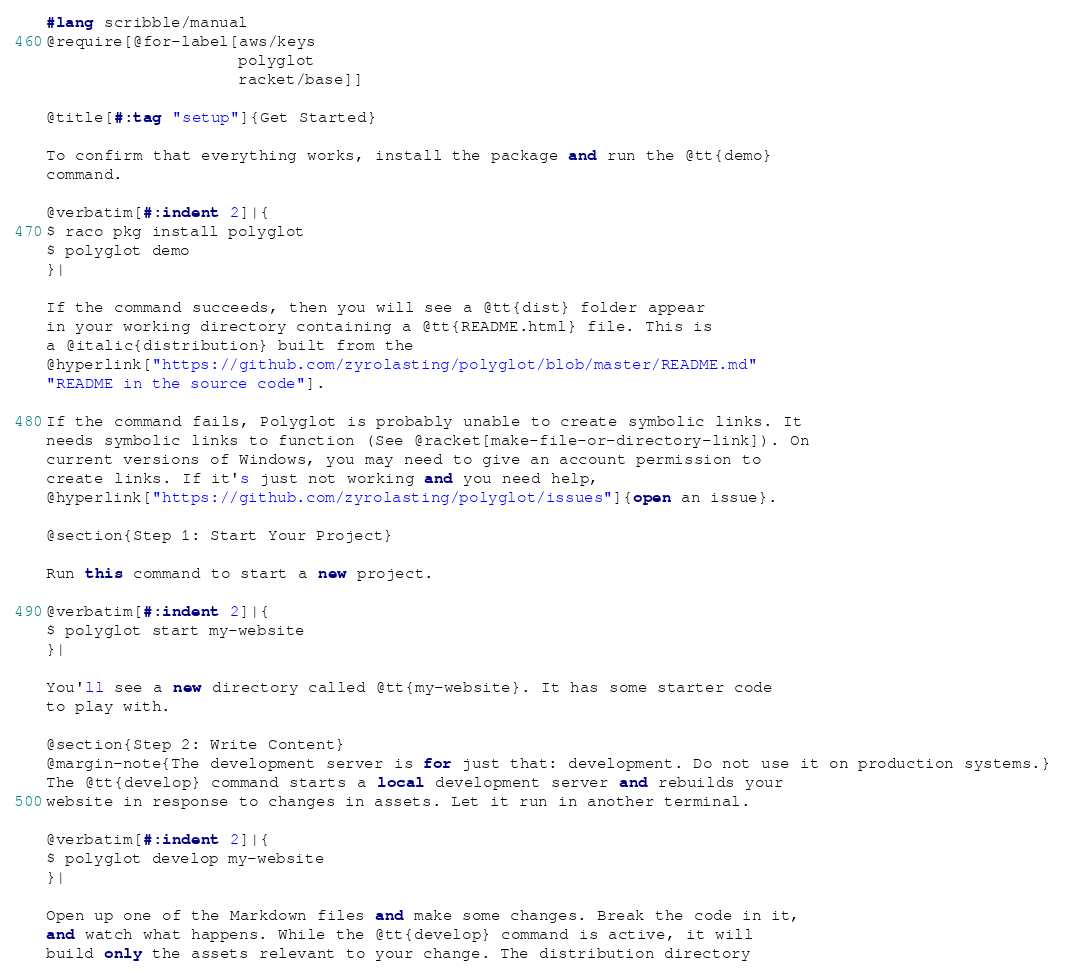<code> <loc_0><loc_0><loc_500><loc_500><_Racket_>#lang scribble/manual
@require[@for-label[aws/keys
                    polyglot
                    racket/base]]

@title[#:tag "setup"]{Get Started}

To confirm that everything works, install the package and run the @tt{demo}
command.

@verbatim[#:indent 2]|{
$ raco pkg install polyglot
$ polyglot demo
}|

If the command succeeds, then you will see a @tt{dist} folder appear
in your working directory containing a @tt{README.html} file. This is
a @italic{distribution} built from the
@hyperlink["https://github.com/zyrolasting/polyglot/blob/master/README.md"
"README in the source code"].

If the command fails, Polyglot is probably unable to create symbolic links. It
needs symbolic links to function (See @racket[make-file-or-directory-link]). On
current versions of Windows, you may need to give an account permission to
create links. If it's just not working and you need help,
@hyperlink["https://github.com/zyrolasting/polyglot/issues"]{open an issue}.

@section{Step 1: Start Your Project}

Run this command to start a new project.

@verbatim[#:indent 2]|{
$ polyglot start my-website
}|

You'll see a new directory called @tt{my-website}. It has some starter code
to play with.

@section{Step 2: Write Content}
@margin-note{The development server is for just that: development. Do not use it on production systems.}
The @tt{develop} command starts a local development server and rebuilds your
website in response to changes in assets. Let it run in another terminal.

@verbatim[#:indent 2]|{
$ polyglot develop my-website
}|

Open up one of the Markdown files and make some changes. Break the code in it,
and watch what happens. While the @tt{develop} command is active, it will
build only the assets relevant to your change. The distribution directory</code> 